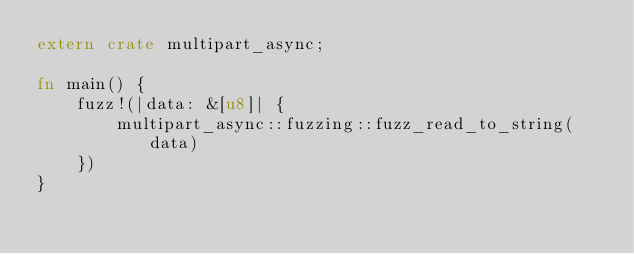<code> <loc_0><loc_0><loc_500><loc_500><_Rust_>extern crate multipart_async;

fn main() {
    fuzz!(|data: &[u8]| {
        multipart_async::fuzzing::fuzz_read_to_string(data)
    })
}
</code> 